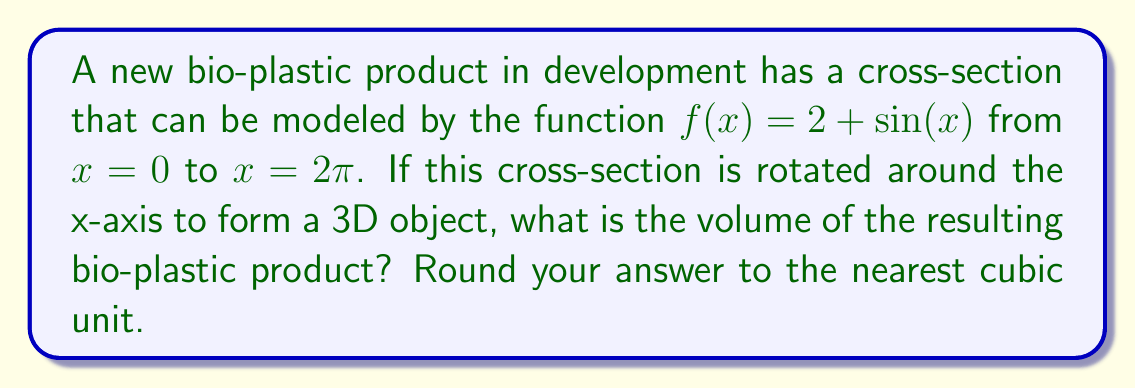Teach me how to tackle this problem. To find the volume of the solid formed by rotating the given function around the x-axis, we need to use the volume formula for solids of revolution:

$$V = \pi \int_a^b [f(x)]^2 dx$$

Where $f(x)$ is our function, and $a$ and $b$ are the limits of integration.

1) Our function is $f(x) = 2 + \sin(x)$, and we're integrating from 0 to $2\pi$.

2) Let's square the function:
   $[f(x)]^2 = (2 + \sin(x))^2 = 4 + 4\sin(x) + \sin^2(x)$

3) Now, we set up our integral:
   $$V = \pi \int_0^{2\pi} (4 + 4\sin(x) + \sin^2(x)) dx$$

4) Let's integrate each term:
   - $\int 4 dx = 4x$
   - $\int 4\sin(x) dx = -4\cos(x)$
   - $\int \sin^2(x) dx = \frac{x}{2} - \frac{\sin(2x)}{4}$

5) Applying the limits of integration:
   $$V = \pi \left[(4x - 4\cos(x) + \frac{x}{2} - \frac{\sin(2x)}{4})\right]_0^{2\pi}$$

6) Evaluating:
   $$V = \pi \left[(8\pi - 4\cos(2\pi) + \pi - \frac{\sin(4\pi)}{4}) - (0 - 4\cos(0) + 0 - \frac{\sin(0)}{4})\right]$$
   $$V = \pi [9\pi - 4 + 4]$$
   $$V = 9\pi^2$$

7) Rounding to the nearest cubic unit:
   $9\pi^2 \approx 88.83 \approx 89$ cubic units
Answer: 89 cubic units 